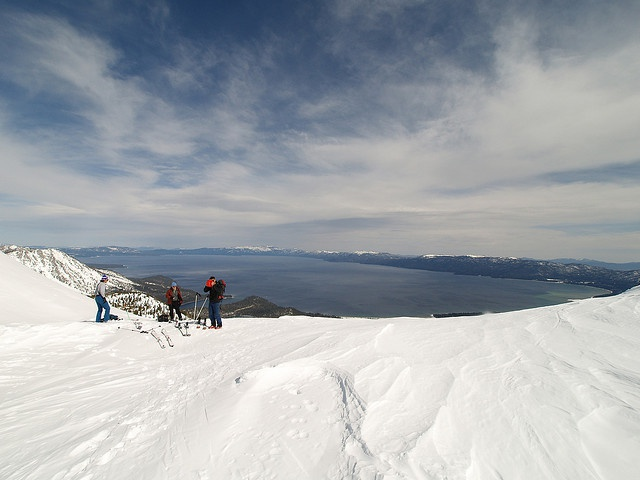Describe the objects in this image and their specific colors. I can see people in blue, black, navy, gray, and brown tones, people in blue, navy, black, and darkgray tones, people in blue, black, maroon, and gray tones, skis in blue, lightgray, darkgray, and gray tones, and skis in blue, white, darkgray, navy, and gray tones in this image. 